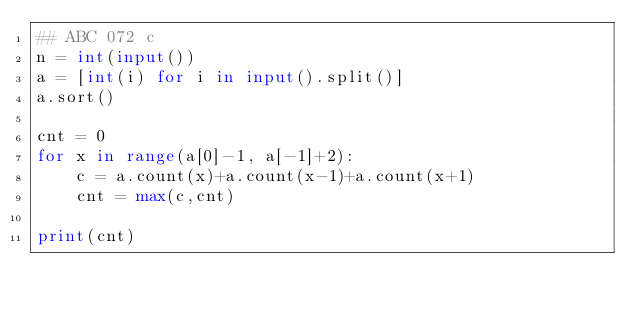Convert code to text. <code><loc_0><loc_0><loc_500><loc_500><_Python_>## ABC 072 c
n = int(input())
a = [int(i) for i in input().split()]
a.sort()

cnt = 0
for x in range(a[0]-1, a[-1]+2):
    c = a.count(x)+a.count(x-1)+a.count(x+1)
    cnt = max(c,cnt)

print(cnt)
</code> 